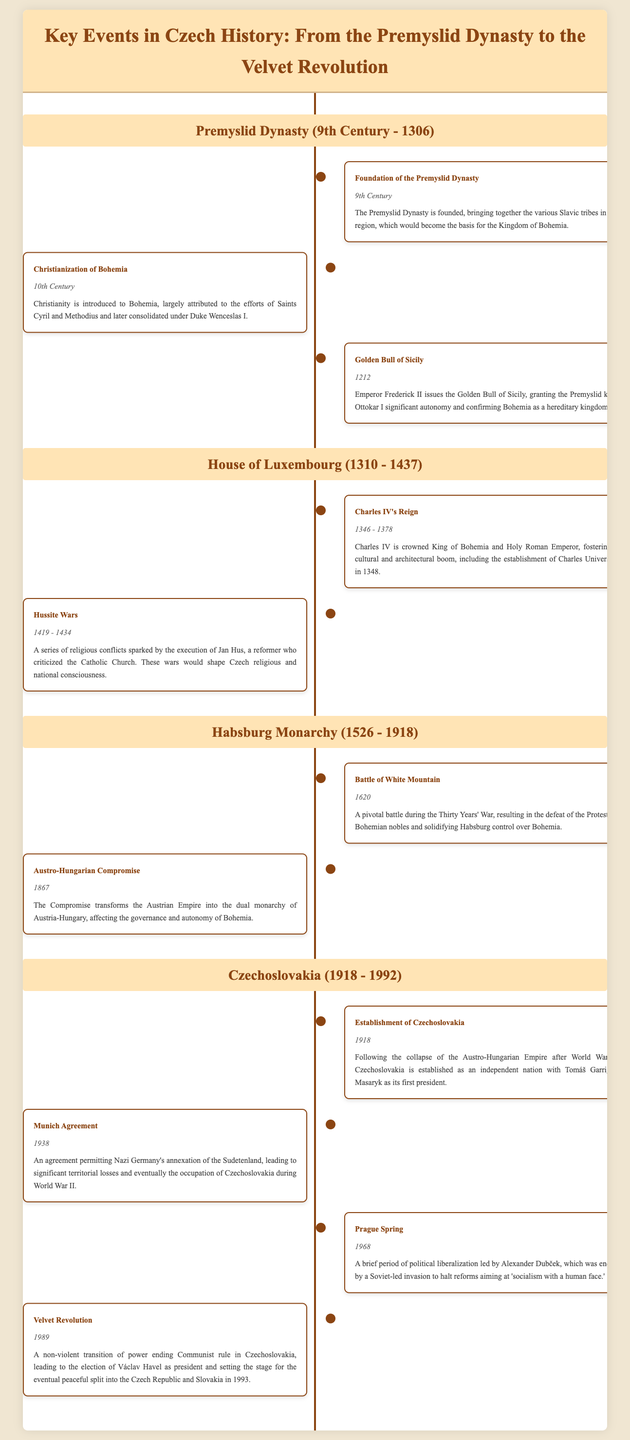What century did the Foundation of the Premyslid Dynasty occur? The event of the foundation of the Premyslid Dynasty happened in the 9th Century.
Answer: 9th Century Who was the first president of Czechoslovakia? The document states that Tomáš Garrigue Masaryk was the first president of Czechoslovakia after its establishment in 1918.
Answer: Tomáš Garrigue Masaryk What significant battle occurred in 1620? The document mentions the Battle of White Mountain as a pivotal battle during the Thirty Years' War in 1620.
Answer: Battle of White Mountain In what year was the Munich Agreement signed? The Munich Agreement, which allowed Nazi Germany's annexation of the Sudetenland, was signed in 1938.
Answer: 1938 What was the aim of the Prague Spring reforms? The reforms of the Prague Spring aimed at establishing 'socialism with a human face' according to the description in the document.
Answer: 'socialism with a human face' Which dynasty is associated with the Christianization of Bohemia? The event detailing the Christianization of Bohemia is linked to the Premyslid Dynasty as indicated in the document.
Answer: Premyslid Dynasty What major event took place in 1989? The Velvet Revolution, a non-violent transition of power ending Communist rule, took place in 1989.
Answer: Velvet Revolution What document type does this information represent? The presented format is classified as a Hierarchical infographic, showcasing key events in Czech history.
Answer: Hierarchical infographic 